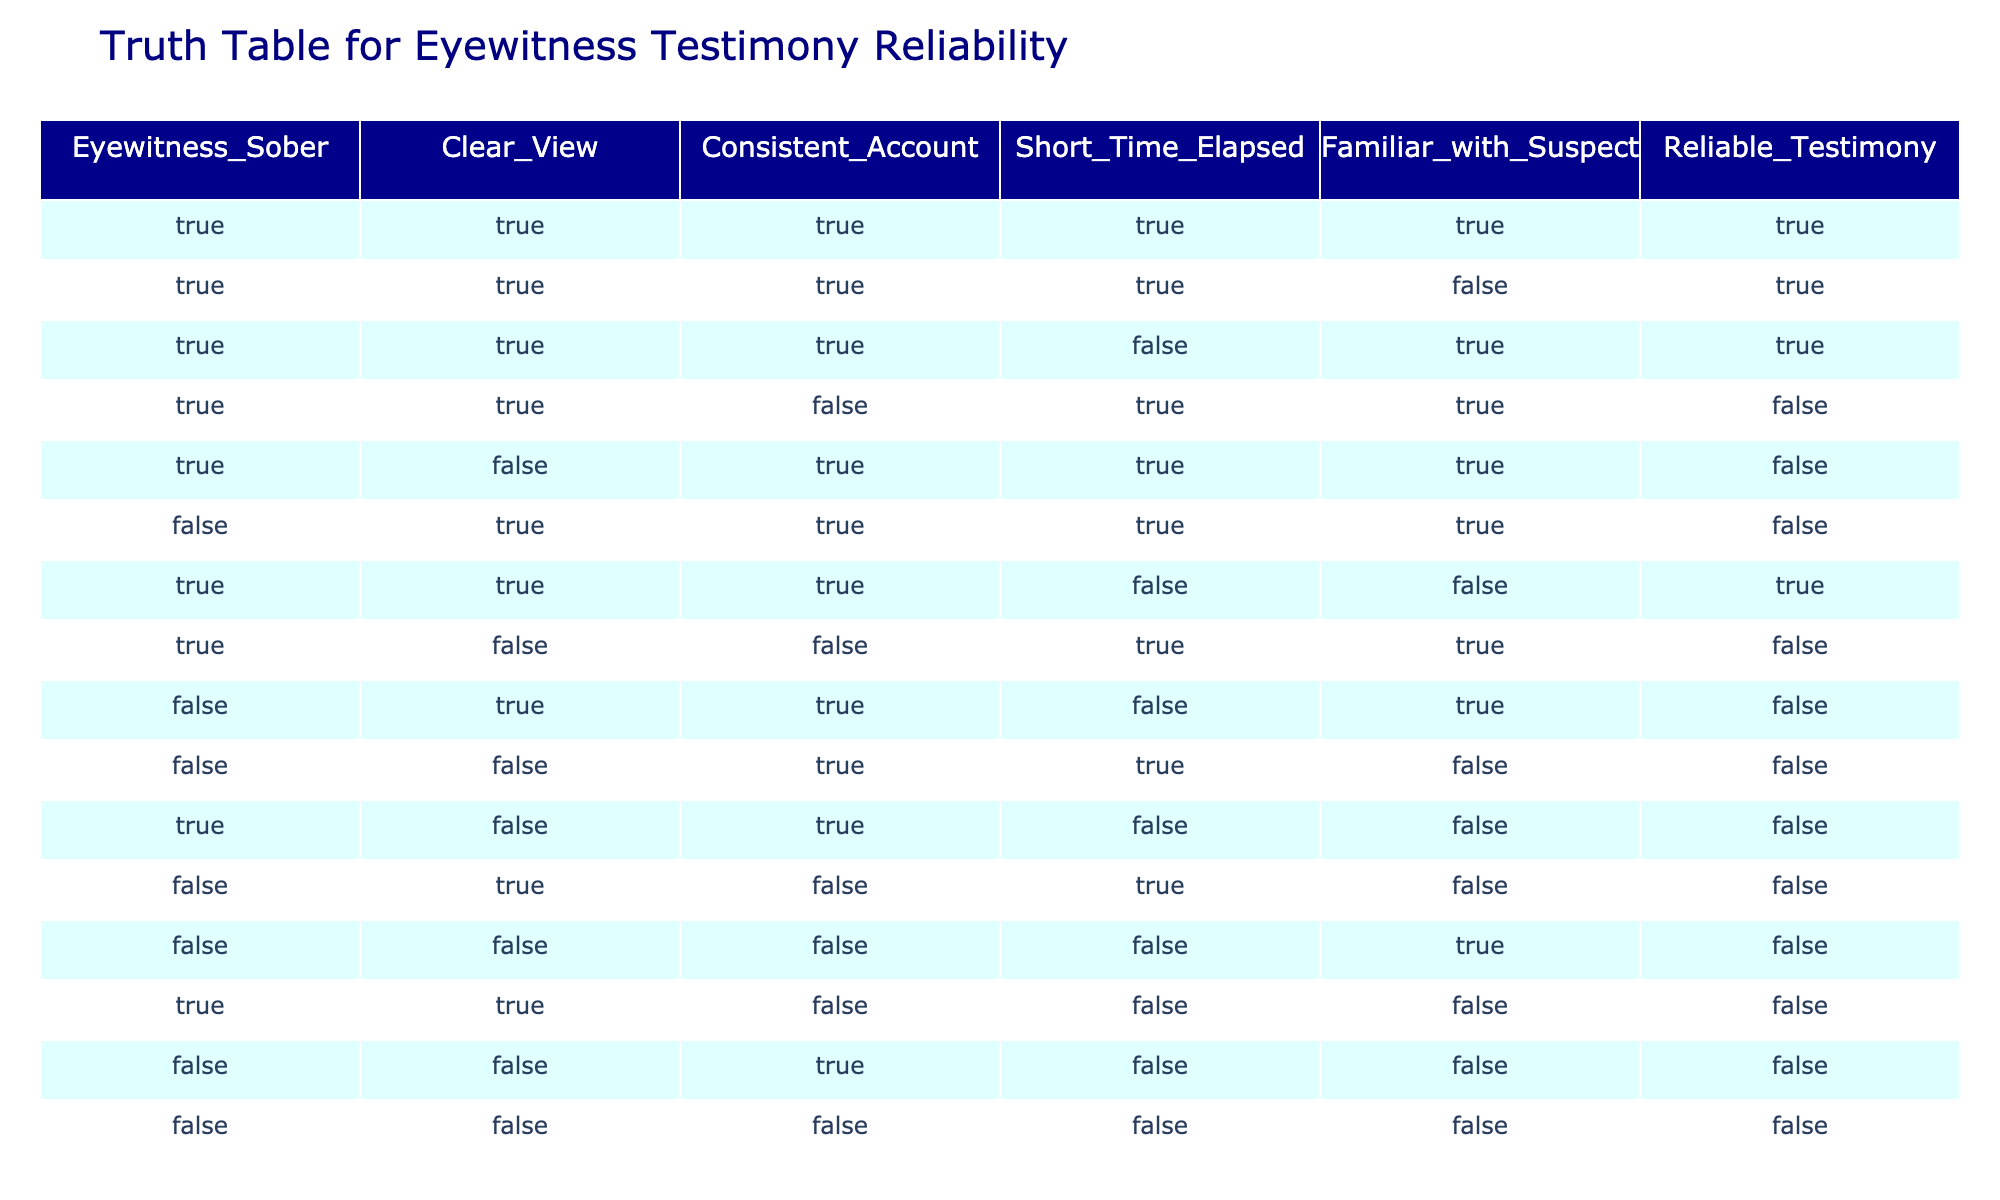What is the total number of reliable testimonies recorded? By counting the number of rows in which "Reliable_Testimony" is True (i.e., the last column), we find that there are 7 instances where the testimony is considered reliable.
Answer: 7 How many testimonies are reliable when the eyewitness is sober? There are 5 rows where "Eyewitness_Sober" is True and "Reliable_Testimony" is also True, indicating that being sober correlates with reliable testimonies.
Answer: 5 What is the reliability status of testimonies when the eyewitness has a clear view and the account is consistent? In the cases where both "Clear_View" and "Consistent_Account" are True, we find 4 instances: 3 reliable and 1 unreliable testimony. This shows that clear visibility and consistency positively impact reliability, though not always.
Answer: 3 reliable, 1 unreliable Are there any testimonies that are unreliable despite the eyewitness being familiar with the suspect? Yes, when "Familiar_with_Suspect" is True, there are 4 instances where the testimony is deemed unreliable across different conditions of sobriety, viewpoint, and account consistency.
Answer: Yes If the eyewitness was neither sober nor had a clear view, what is the reliability of their testimonies? Analyzing the rows where "Eyewitness_Sober" is False and "Clear_View" is False, we find that all 3 testimonies are unreliable, indicating a significant impact on reliability due to these factors.
Answer: Unreliable 